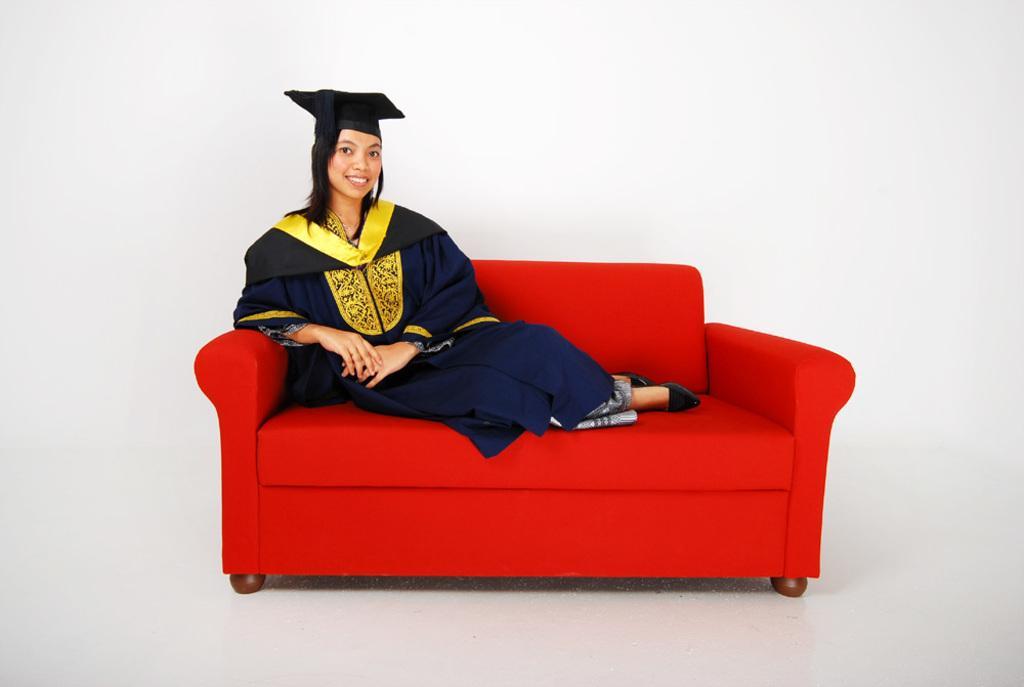How would you summarize this image in a sentence or two? In this image, there is a woman sitting on the chair, wearing a uniform and black color hat on red color sofa. The background wall is white in color. This picture is taken inside a hall. 